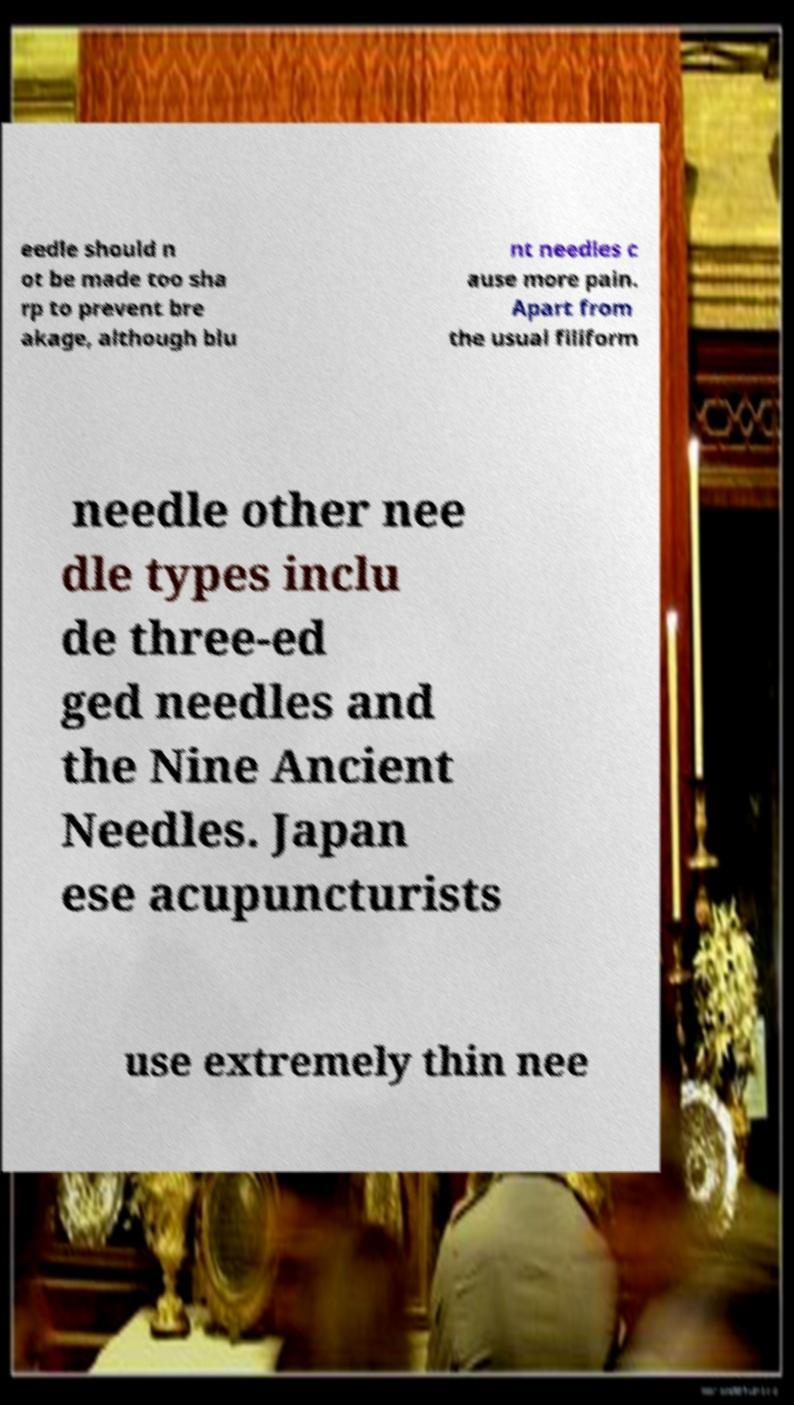Can you read and provide the text displayed in the image?This photo seems to have some interesting text. Can you extract and type it out for me? eedle should n ot be made too sha rp to prevent bre akage, although blu nt needles c ause more pain. Apart from the usual filiform needle other nee dle types inclu de three-ed ged needles and the Nine Ancient Needles. Japan ese acupuncturists use extremely thin nee 